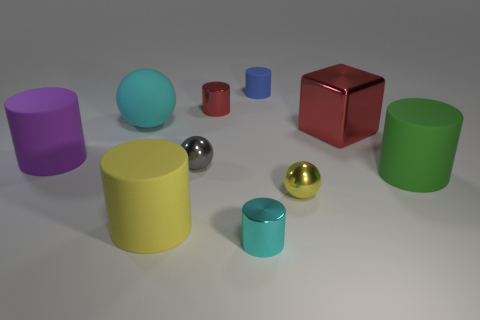What material is the red object that is to the right of the small yellow ball?
Provide a short and direct response. Metal. There is a tiny metallic cylinder in front of the small sphere that is behind the large cylinder that is to the right of the small rubber cylinder; what is its color?
Ensure brevity in your answer.  Cyan. There is another shiny ball that is the same size as the yellow metal sphere; what is its color?
Ensure brevity in your answer.  Gray. How many matte objects are either blue objects or large green cylinders?
Provide a short and direct response. 2. There is a sphere that is the same material as the tiny blue cylinder; what is its color?
Your answer should be very brief. Cyan. There is a cyan object that is behind the matte cylinder to the right of the blue cylinder; what is its material?
Your response must be concise. Rubber. How many objects are big things to the left of the tiny blue matte cylinder or small objects left of the tiny cyan object?
Give a very brief answer. 5. There is a yellow thing on the left side of the cyan thing right of the cyan sphere left of the small blue cylinder; what size is it?
Make the answer very short. Large. Are there the same number of small yellow metal objects behind the tiny red cylinder and red metallic objects?
Your response must be concise. No. Is there any other thing that has the same shape as the big cyan matte thing?
Your response must be concise. Yes. 